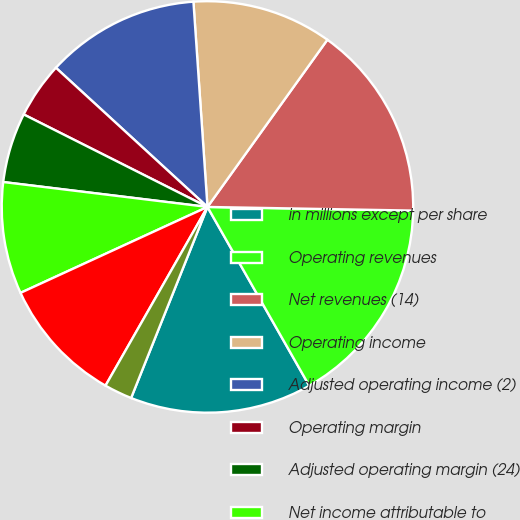Convert chart to OTSL. <chart><loc_0><loc_0><loc_500><loc_500><pie_chart><fcel>in millions except per share<fcel>Operating revenues<fcel>Net revenues (14)<fcel>Operating income<fcel>Adjusted operating income (2)<fcel>Operating margin<fcel>Adjusted operating margin (24)<fcel>Net income attributable to<fcel>Adjusted net income (3)<fcel>-basic<nl><fcel>14.29%<fcel>16.48%<fcel>15.38%<fcel>10.99%<fcel>12.09%<fcel>4.4%<fcel>5.49%<fcel>8.79%<fcel>9.89%<fcel>2.2%<nl></chart> 